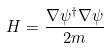<formula> <loc_0><loc_0><loc_500><loc_500>H = \frac { \nabla \psi ^ { \dagger } \nabla \psi } { 2 m }</formula> 